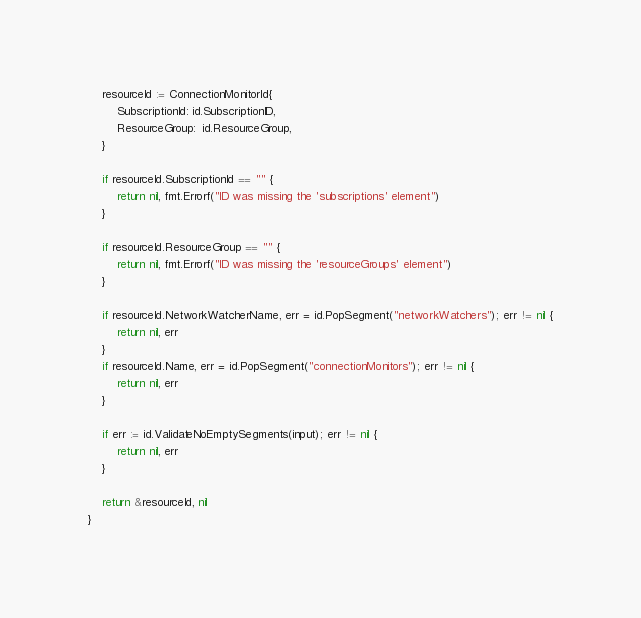<code> <loc_0><loc_0><loc_500><loc_500><_Go_>	resourceId := ConnectionMonitorId{
		SubscriptionId: id.SubscriptionID,
		ResourceGroup:  id.ResourceGroup,
	}

	if resourceId.SubscriptionId == "" {
		return nil, fmt.Errorf("ID was missing the 'subscriptions' element")
	}

	if resourceId.ResourceGroup == "" {
		return nil, fmt.Errorf("ID was missing the 'resourceGroups' element")
	}

	if resourceId.NetworkWatcherName, err = id.PopSegment("networkWatchers"); err != nil {
		return nil, err
	}
	if resourceId.Name, err = id.PopSegment("connectionMonitors"); err != nil {
		return nil, err
	}

	if err := id.ValidateNoEmptySegments(input); err != nil {
		return nil, err
	}

	return &resourceId, nil
}
</code> 